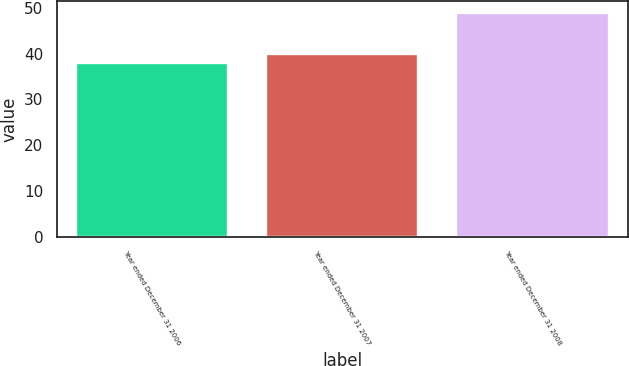Convert chart to OTSL. <chart><loc_0><loc_0><loc_500><loc_500><bar_chart><fcel>Year ended December 31 2006<fcel>Year ended December 31 2007<fcel>Year ended December 31 2008<nl><fcel>38<fcel>40<fcel>49<nl></chart> 